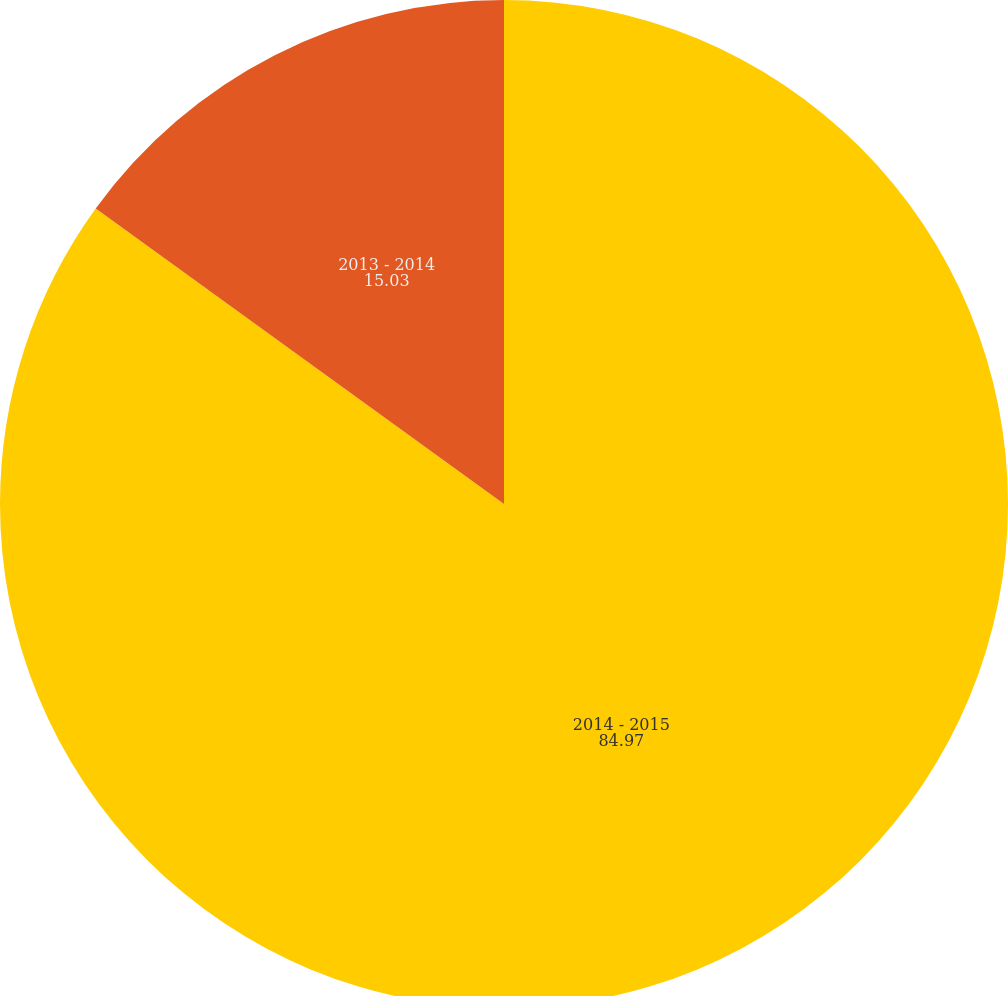Convert chart to OTSL. <chart><loc_0><loc_0><loc_500><loc_500><pie_chart><fcel>2014 - 2015<fcel>2013 - 2014<nl><fcel>84.97%<fcel>15.03%<nl></chart> 